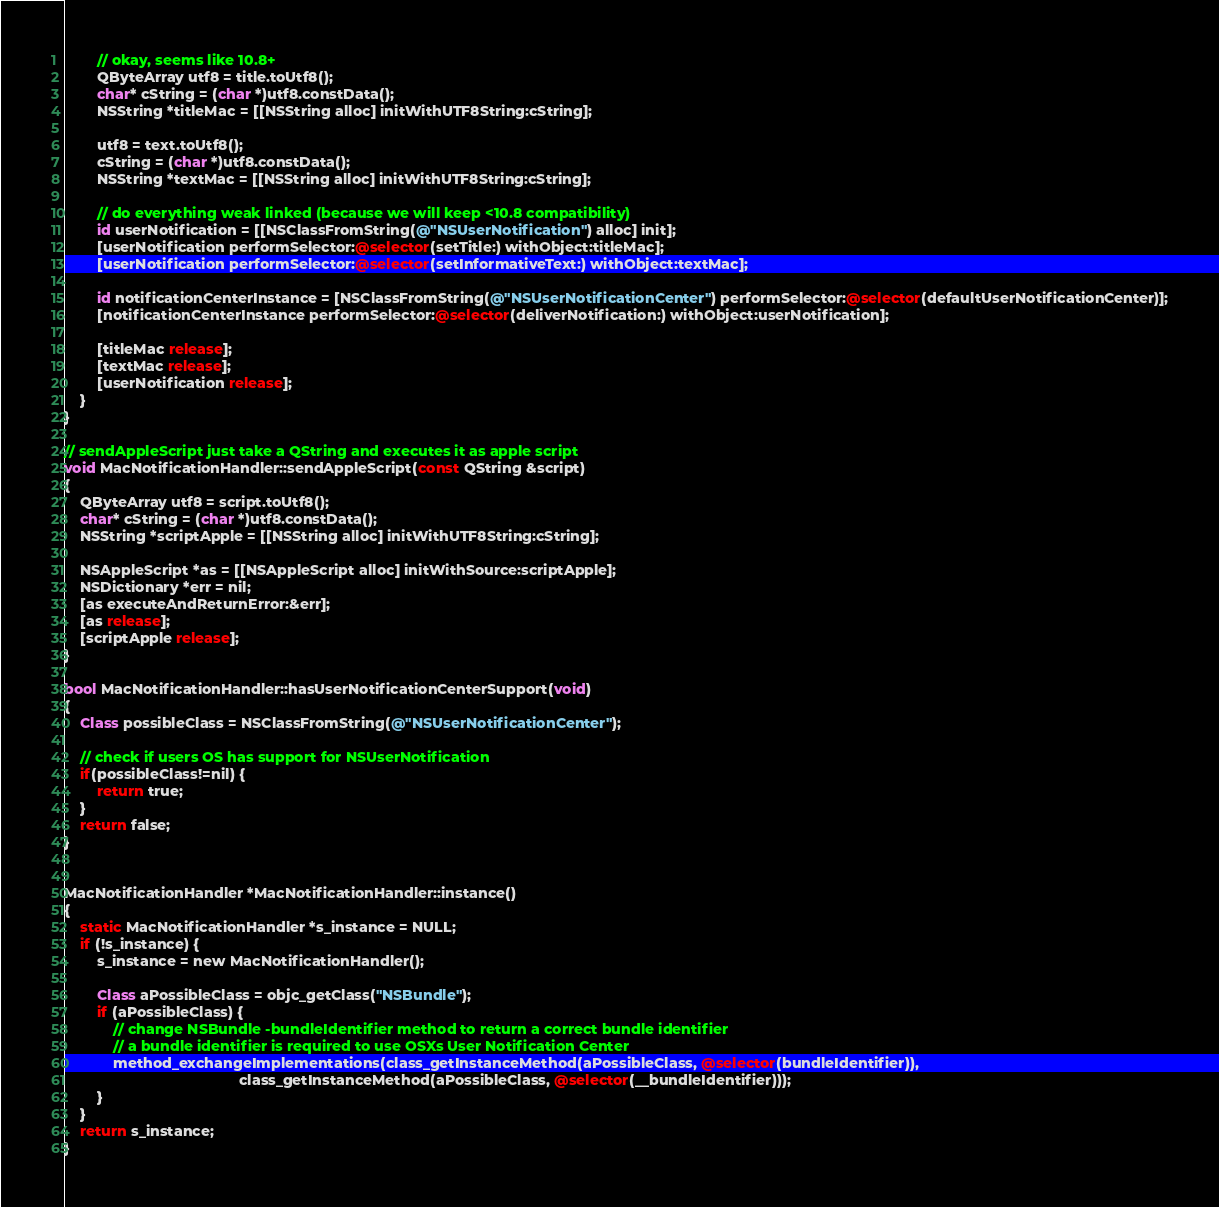Convert code to text. <code><loc_0><loc_0><loc_500><loc_500><_ObjectiveC_>        // okay, seems like 10.8+
        QByteArray utf8 = title.toUtf8();
        char* cString = (char *)utf8.constData();
        NSString *titleMac = [[NSString alloc] initWithUTF8String:cString];

        utf8 = text.toUtf8();
        cString = (char *)utf8.constData();
        NSString *textMac = [[NSString alloc] initWithUTF8String:cString];

        // do everything weak linked (because we will keep <10.8 compatibility)
        id userNotification = [[NSClassFromString(@"NSUserNotification") alloc] init];
        [userNotification performSelector:@selector(setTitle:) withObject:titleMac];
        [userNotification performSelector:@selector(setInformativeText:) withObject:textMac];

        id notificationCenterInstance = [NSClassFromString(@"NSUserNotificationCenter") performSelector:@selector(defaultUserNotificationCenter)];
        [notificationCenterInstance performSelector:@selector(deliverNotification:) withObject:userNotification];

        [titleMac release];
        [textMac release];
        [userNotification release];
    }
}

// sendAppleScript just take a QString and executes it as apple script
void MacNotificationHandler::sendAppleScript(const QString &script)
{
    QByteArray utf8 = script.toUtf8();
    char* cString = (char *)utf8.constData();
    NSString *scriptApple = [[NSString alloc] initWithUTF8String:cString];

    NSAppleScript *as = [[NSAppleScript alloc] initWithSource:scriptApple];
    NSDictionary *err = nil;
    [as executeAndReturnError:&err];
    [as release];
    [scriptApple release];
}

bool MacNotificationHandler::hasUserNotificationCenterSupport(void)
{
    Class possibleClass = NSClassFromString(@"NSUserNotificationCenter");

    // check if users OS has support for NSUserNotification
    if(possibleClass!=nil) {
        return true;
    }
    return false;
}


MacNotificationHandler *MacNotificationHandler::instance()
{
    static MacNotificationHandler *s_instance = NULL;
    if (!s_instance) {
        s_instance = new MacNotificationHandler();
        
        Class aPossibleClass = objc_getClass("NSBundle");
        if (aPossibleClass) {
            // change NSBundle -bundleIdentifier method to return a correct bundle identifier
            // a bundle identifier is required to use OSXs User Notification Center
            method_exchangeImplementations(class_getInstanceMethod(aPossibleClass, @selector(bundleIdentifier)),
                                           class_getInstanceMethod(aPossibleClass, @selector(__bundleIdentifier)));
        }
    }
    return s_instance;
}
</code> 